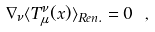Convert formula to latex. <formula><loc_0><loc_0><loc_500><loc_500>\nabla _ { \nu } \langle T _ { \mu } ^ { \nu } ( x ) \rangle _ { R e n . } = 0 \ ,</formula> 